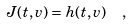<formula> <loc_0><loc_0><loc_500><loc_500>J ( t , v ) = h ( t , v ) \ \ ,</formula> 